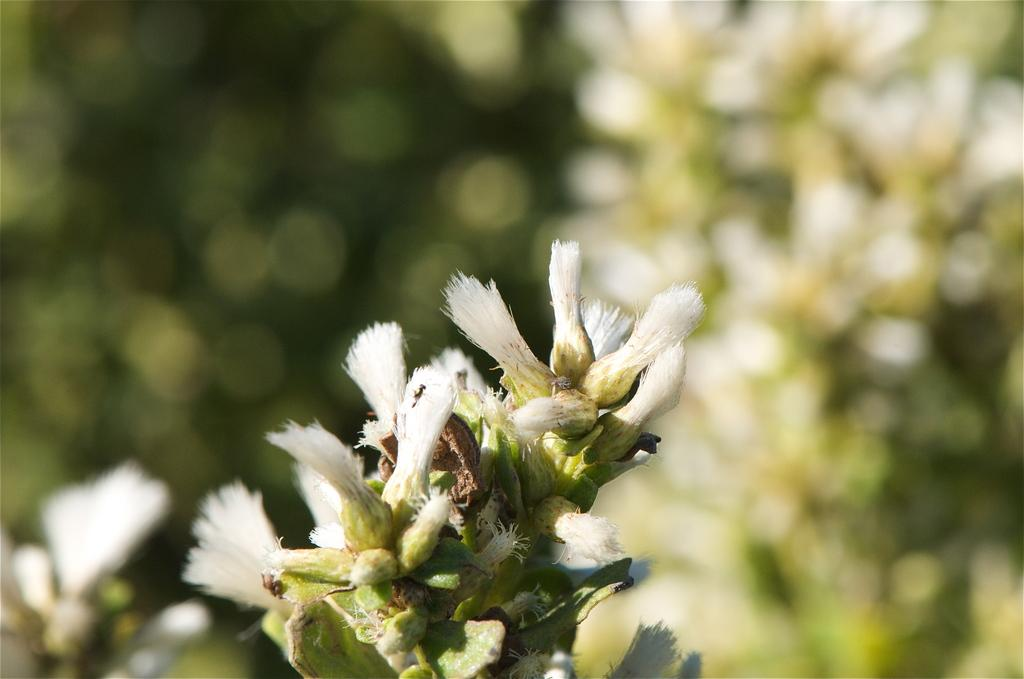What type of plants can be seen in the image? There are flowers in the image. What color are the flowers? The flowers are white in color. What type of joke does the cat tell in the image? There is no cat or joke present in the image; it only features white flowers. How much honey can be seen dripping from the flowers in the image? There is no honey present in the image; it only features white flowers. 